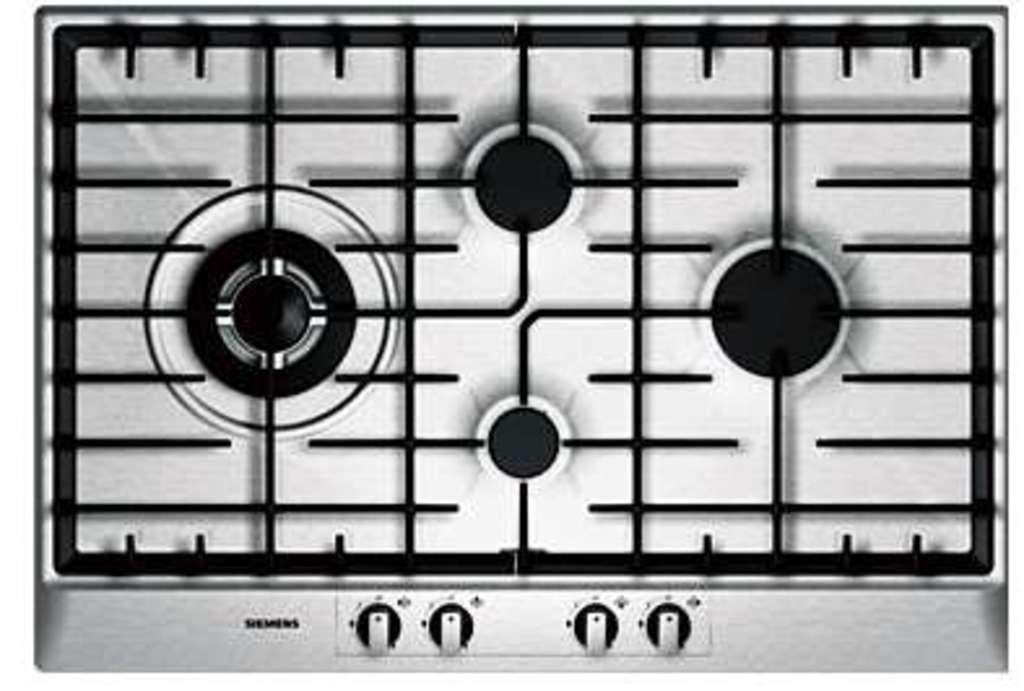What is the color scheme of the image? The image is black and white. What type of appliance can be seen in the picture? There is a gas stove in the picture. What feature of the gas stove is visible? The gas stove has a burner and a few rods. What else can be seen in the picture besides the gas stove? There is some text visible in the picture, and there are buttons at the bottom of the picture. What type of suit is hanging on the wall in the image? There is no suit present in the image; it features a gas stove and other elements. How many potatoes are visible on the gas stove in the image? There are no potatoes visible on the gas stove in the image. 